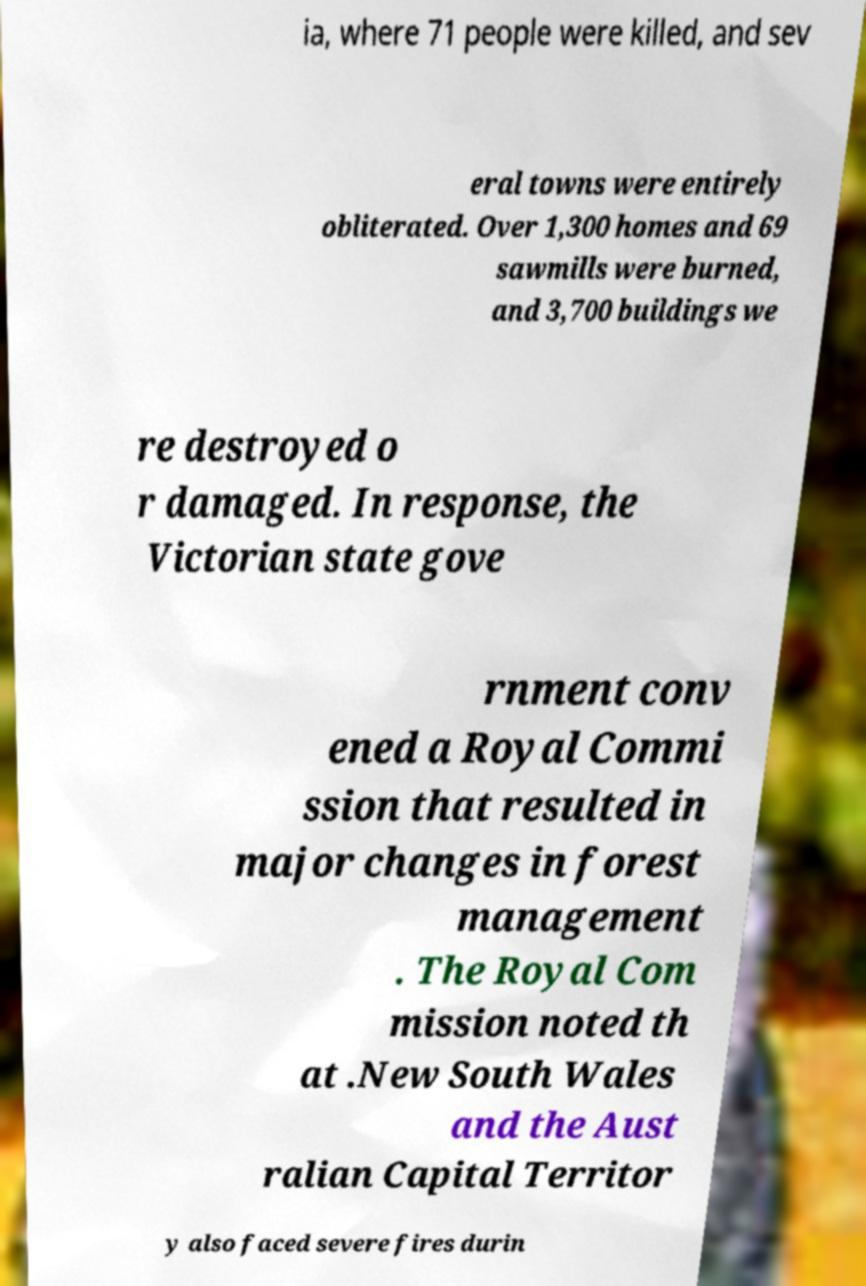Can you accurately transcribe the text from the provided image for me? ia, where 71 people were killed, and sev eral towns were entirely obliterated. Over 1,300 homes and 69 sawmills were burned, and 3,700 buildings we re destroyed o r damaged. In response, the Victorian state gove rnment conv ened a Royal Commi ssion that resulted in major changes in forest management . The Royal Com mission noted th at .New South Wales and the Aust ralian Capital Territor y also faced severe fires durin 